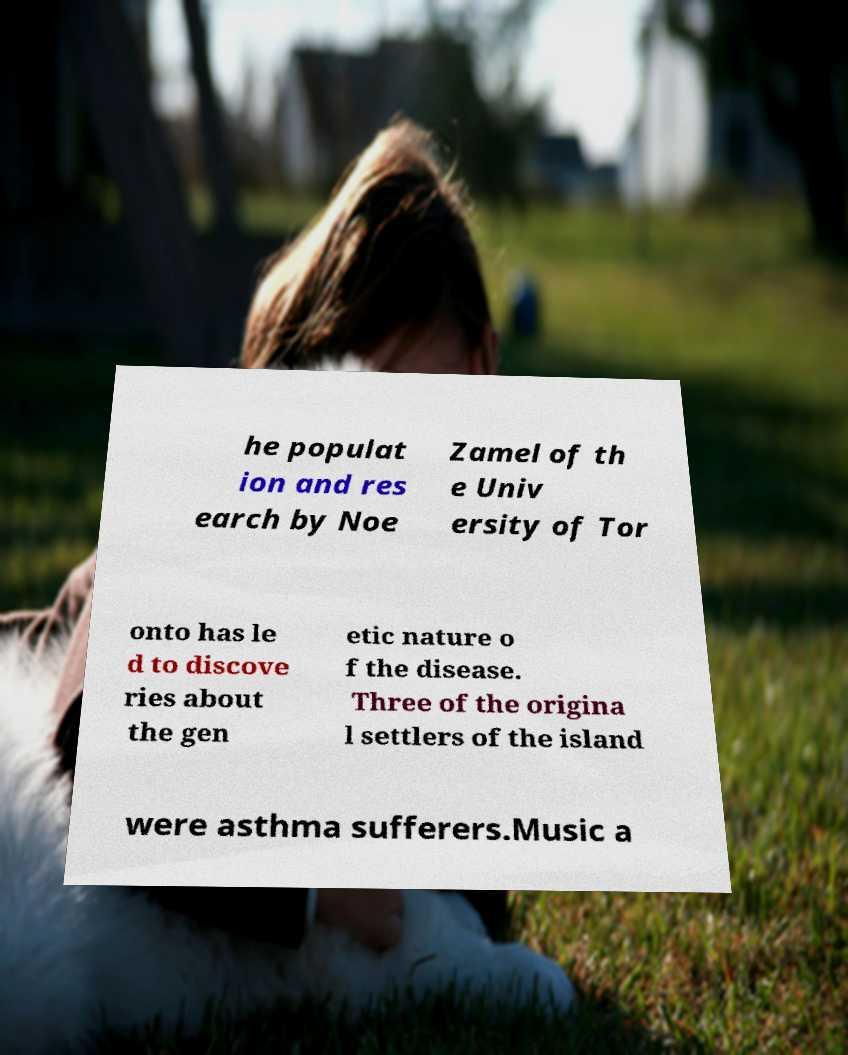There's text embedded in this image that I need extracted. Can you transcribe it verbatim? he populat ion and res earch by Noe Zamel of th e Univ ersity of Tor onto has le d to discove ries about the gen etic nature o f the disease. Three of the origina l settlers of the island were asthma sufferers.Music a 